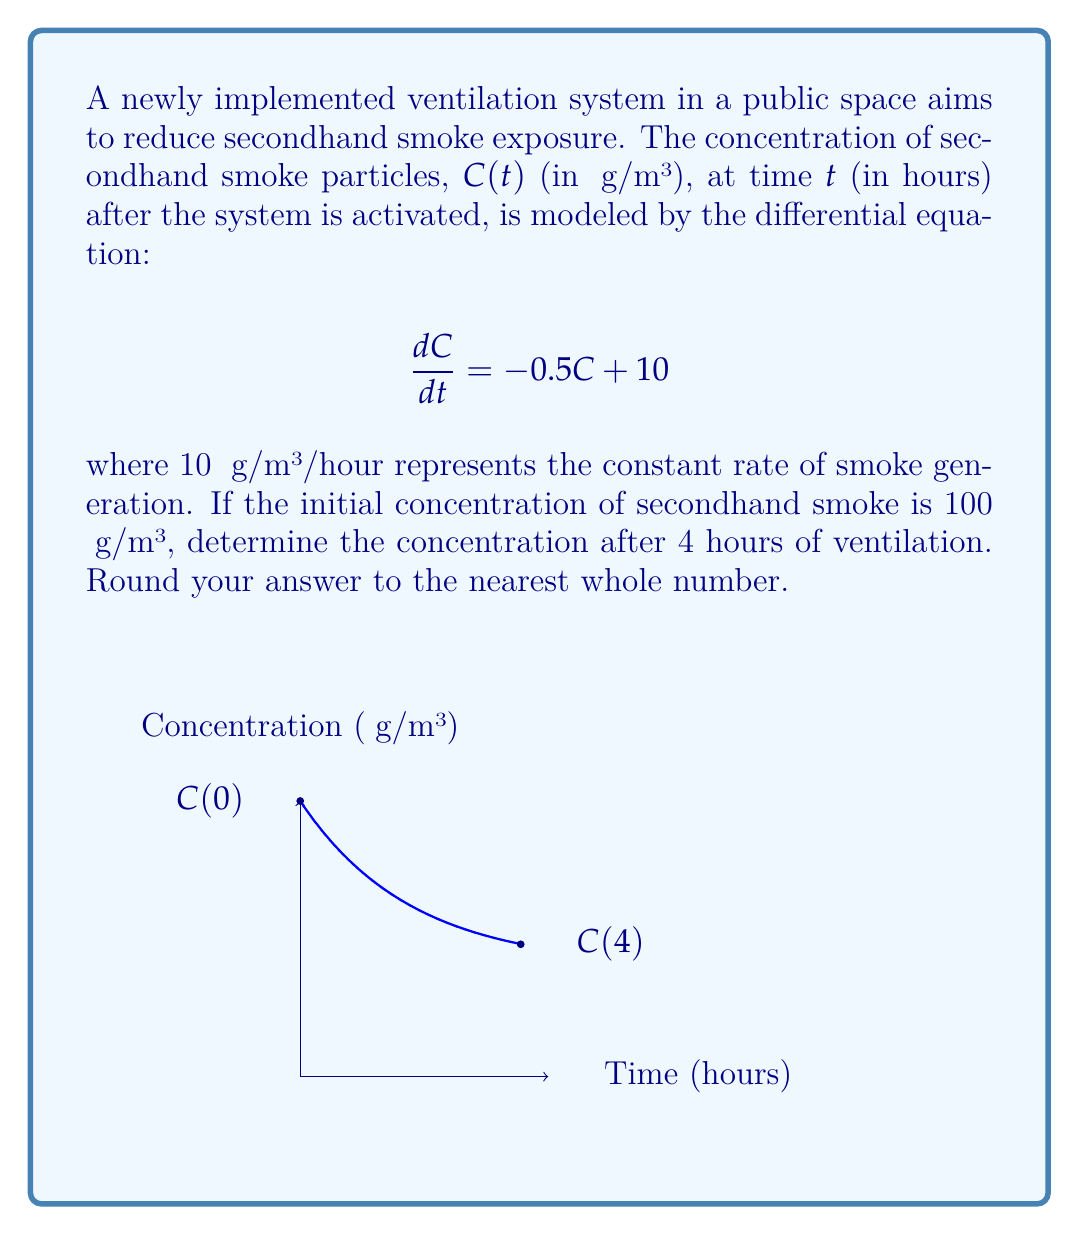Can you solve this math problem? Let's solve this problem step-by-step:

1) The given differential equation is:
   $$\frac{dC}{dt} = -0.5C + 10$$

2) This is a first-order linear differential equation. The general solution is:
   $$C(t) = Ce^{-0.5t} + 20$$
   where $C$ is a constant to be determined.

3) We use the initial condition to find $C$:
   At $t=0$, $C(0) = 100$
   $$100 = C + 20$$
   $$C = 80$$

4) Therefore, the particular solution is:
   $$C(t) = 80e^{-0.5t} + 20$$

5) To find the concentration after 4 hours, we evaluate $C(4)$:
   $$C(4) = 80e^{-0.5(4)} + 20$$
   $$C(4) = 80e^{-2} + 20$$

6) Calculate:
   $$C(4) = 80(0.1353) + 20 = 10.824 + 20 = 30.824$$

7) Rounding to the nearest whole number:
   $$C(4) ≈ 31 \text{ μg/m³}$$
Answer: 31 μg/m³ 